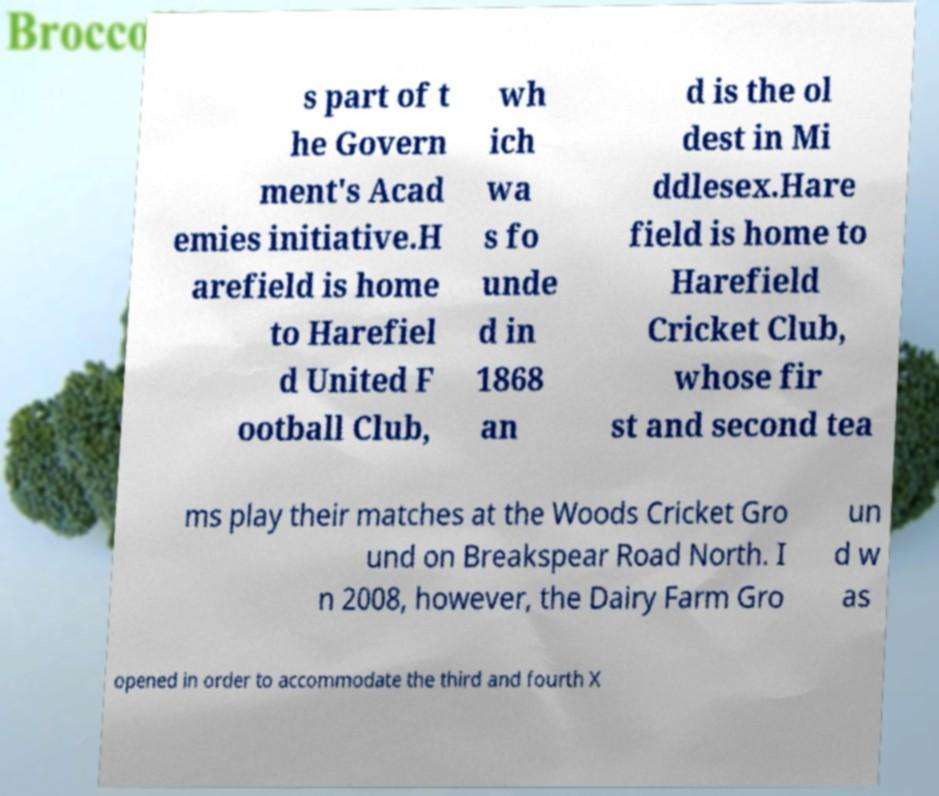Could you assist in decoding the text presented in this image and type it out clearly? s part of t he Govern ment's Acad emies initiative.H arefield is home to Harefiel d United F ootball Club, wh ich wa s fo unde d in 1868 an d is the ol dest in Mi ddlesex.Hare field is home to Harefield Cricket Club, whose fir st and second tea ms play their matches at the Woods Cricket Gro und on Breakspear Road North. I n 2008, however, the Dairy Farm Gro un d w as opened in order to accommodate the third and fourth X 